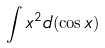<formula> <loc_0><loc_0><loc_500><loc_500>\int x ^ { 2 } d ( \cos x )</formula> 